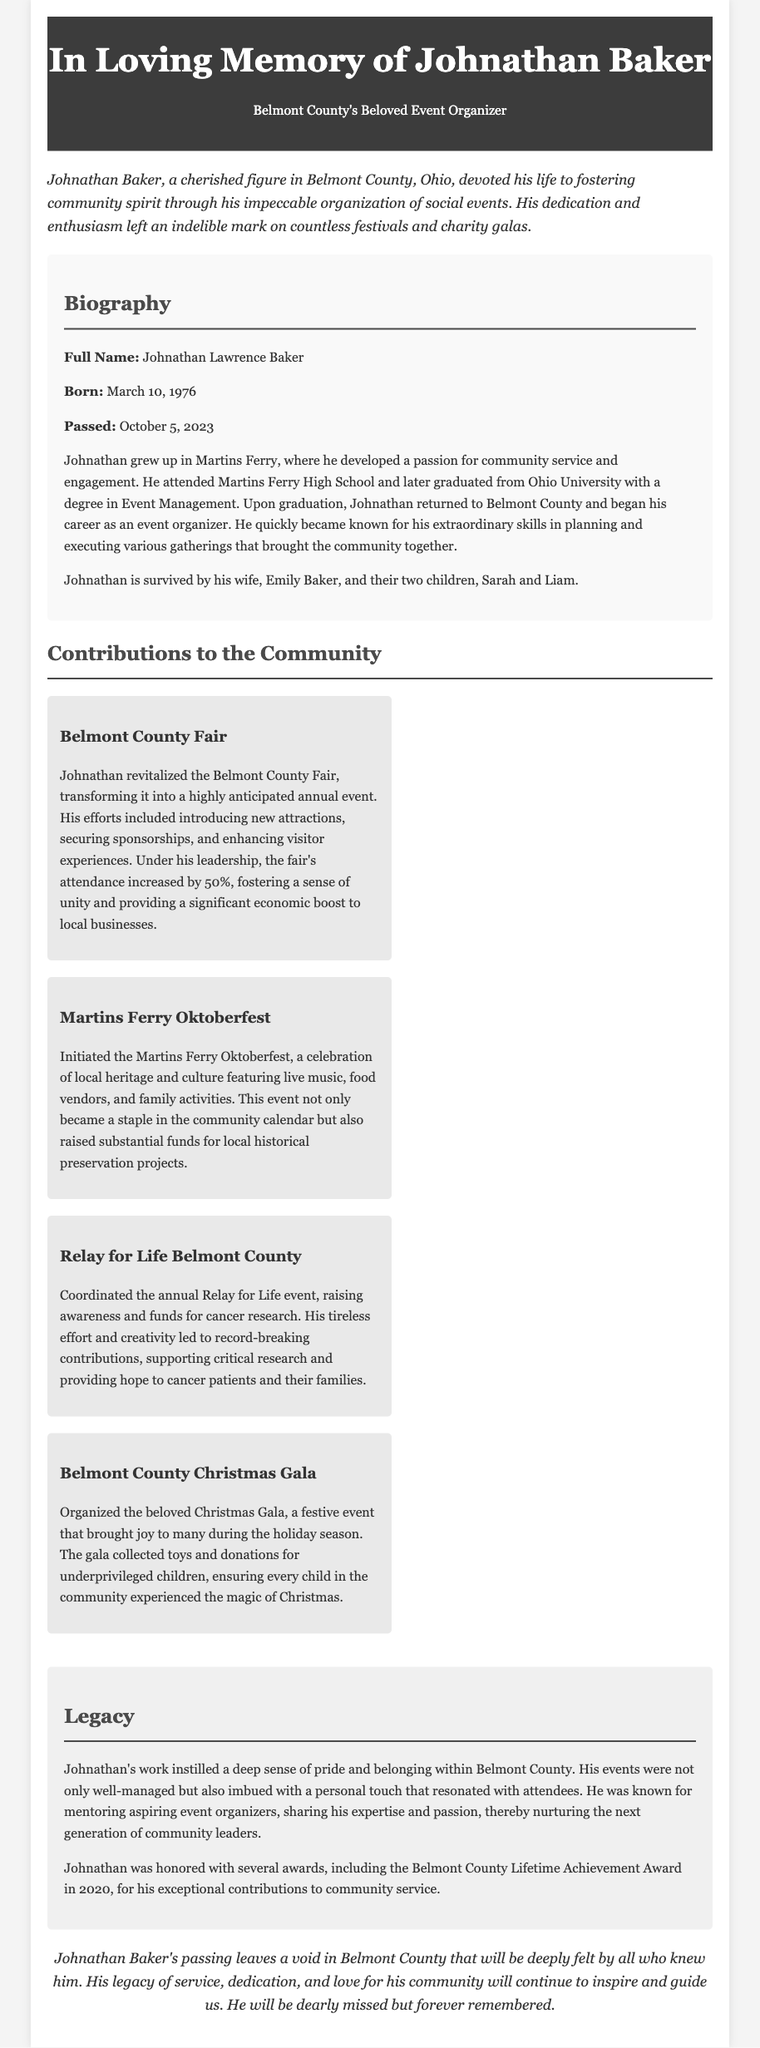What was Johnathan Baker's full name? Johnathan's full name is provided in the biography section of the document.
Answer: Johnathan Lawrence Baker When was Johnathan born? The document specifies the birth date in the biography section.
Answer: March 10, 1976 What event did Johnathan revitalize? The document states that he revitalized the Belmont County Fair.
Answer: Belmont County Fair How much did the attendance increase by at the Belmont County Fair? The document mentions a specific percentage increase in attendance under his leadership.
Answer: 50% What recognition did Johnathan receive in 2020? The document lists the award he received for his contributions to community service.
Answer: Belmont County Lifetime Achievement Award What was the purpose of the Martins Ferry Oktoberfest? The document explains the event's focus on local heritage and its fundraising aspects.
Answer: Local heritage and culture How did Johnathan contribute to the Relay for Life event? The document describes his role in raising awareness and funds for cancer research.
Answer: Coordinated What personal quality was Johnathan known for in relation to aspiring event organizers? The document highlights a specific attribute related to his interaction with budding event organizers.
Answer: Mentoring What was the goal of the Belmont County Christmas Gala? The document outlines a specific purpose of the Christmas Gala in the community.
Answer: Collecting toys and donations for underprivileged children 